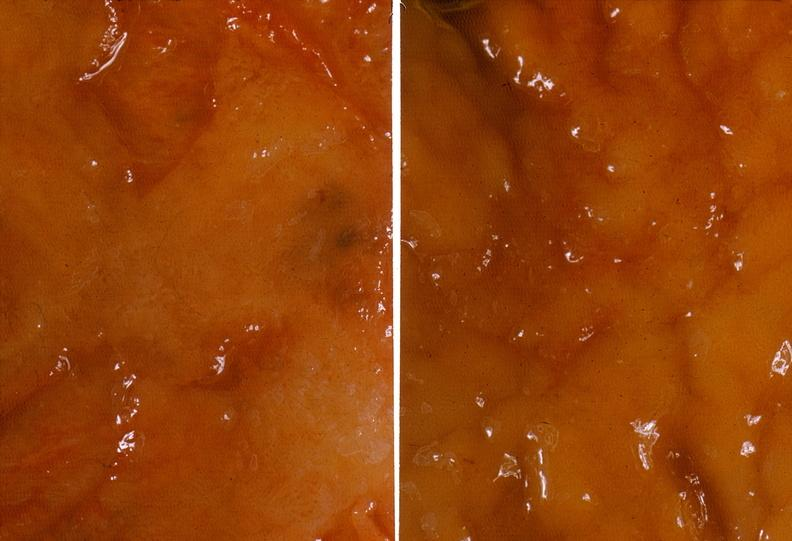where does this belong to?
Answer the question using a single word or phrase. Gastrointestinal system 